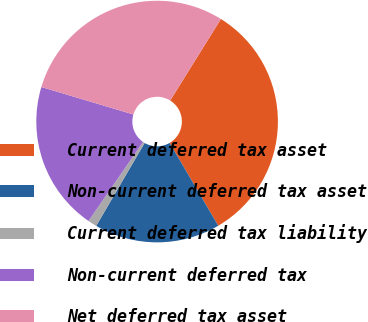Convert chart. <chart><loc_0><loc_0><loc_500><loc_500><pie_chart><fcel>Current deferred tax asset<fcel>Non-current deferred tax asset<fcel>Current deferred tax liability<fcel>Non-current deferred tax<fcel>Net deferred tax asset<nl><fcel>32.7%<fcel>16.86%<fcel>1.2%<fcel>20.01%<fcel>29.24%<nl></chart> 